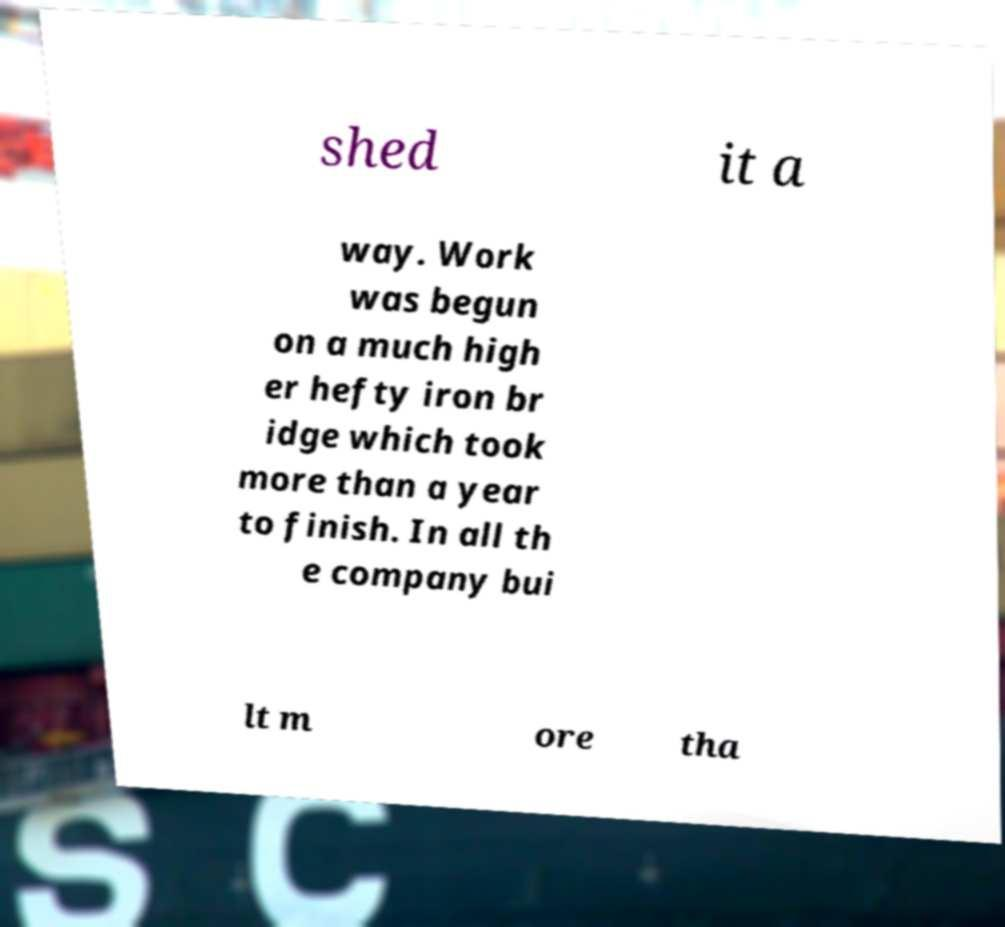Could you assist in decoding the text presented in this image and type it out clearly? shed it a way. Work was begun on a much high er hefty iron br idge which took more than a year to finish. In all th e company bui lt m ore tha 